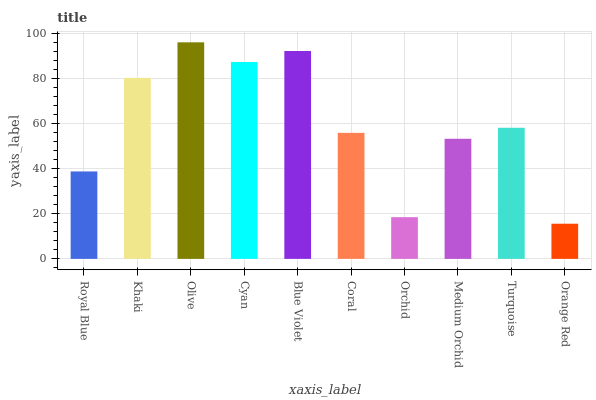Is Orange Red the minimum?
Answer yes or no. Yes. Is Olive the maximum?
Answer yes or no. Yes. Is Khaki the minimum?
Answer yes or no. No. Is Khaki the maximum?
Answer yes or no. No. Is Khaki greater than Royal Blue?
Answer yes or no. Yes. Is Royal Blue less than Khaki?
Answer yes or no. Yes. Is Royal Blue greater than Khaki?
Answer yes or no. No. Is Khaki less than Royal Blue?
Answer yes or no. No. Is Turquoise the high median?
Answer yes or no. Yes. Is Coral the low median?
Answer yes or no. Yes. Is Olive the high median?
Answer yes or no. No. Is Olive the low median?
Answer yes or no. No. 